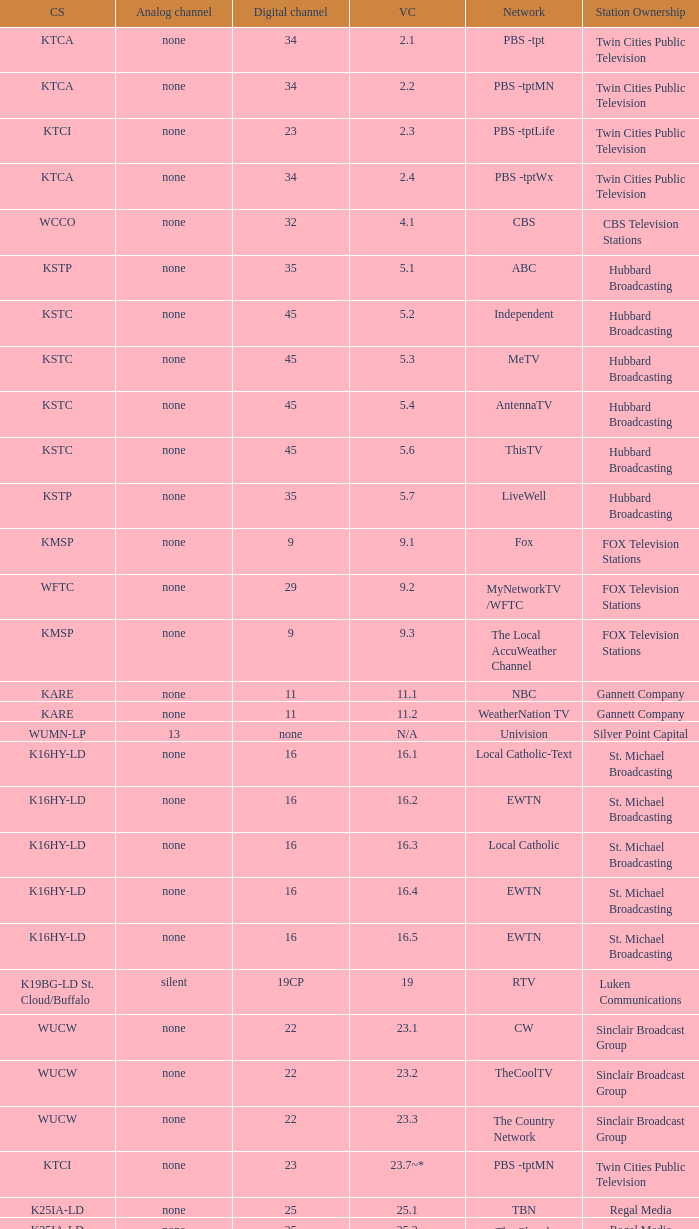Station Ownership of eicb tv, and a Call sign of ktcj-ld is what virtual network? 50.1. 